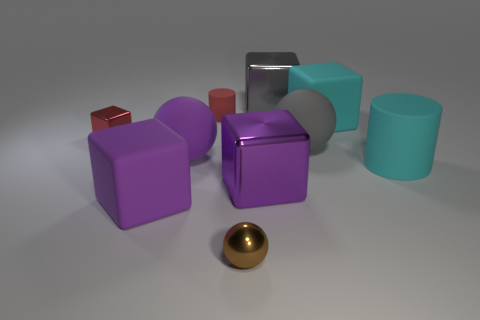There is a cube that is the same size as the metal ball; what is its color? The cube that matches the size of the metal ball is actually purple, not red. It stands as a striking object amidst a collection of other geometric shapes, each with its own distinct hue. 